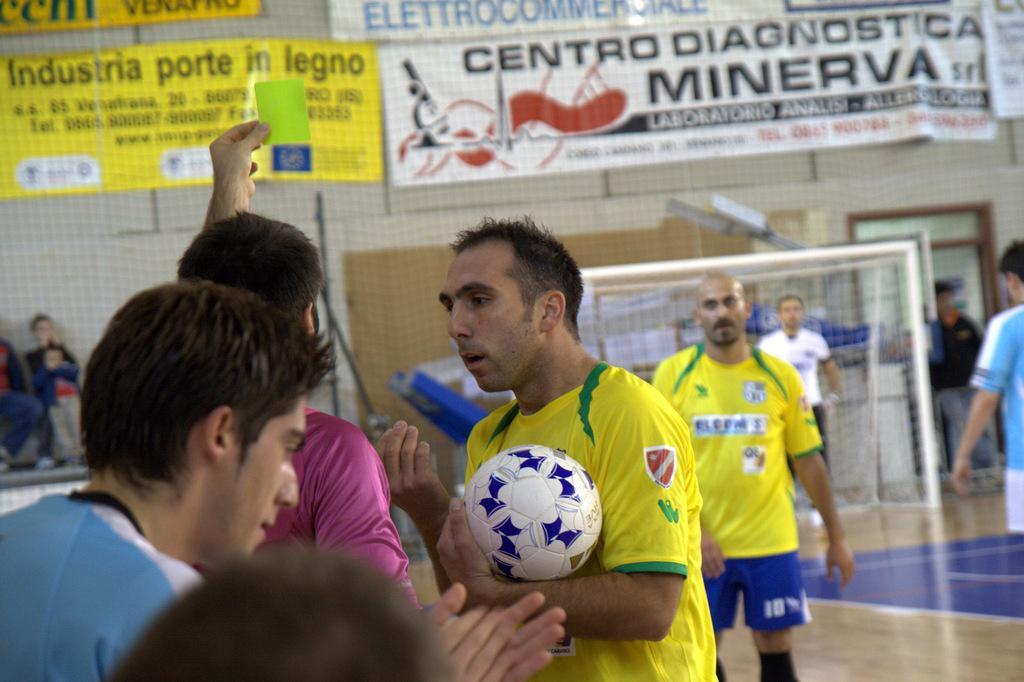Describe this image in one or two sentences. In this image there are group of people standing on the floor. At the back side there is a net. The person is holding the ball. 